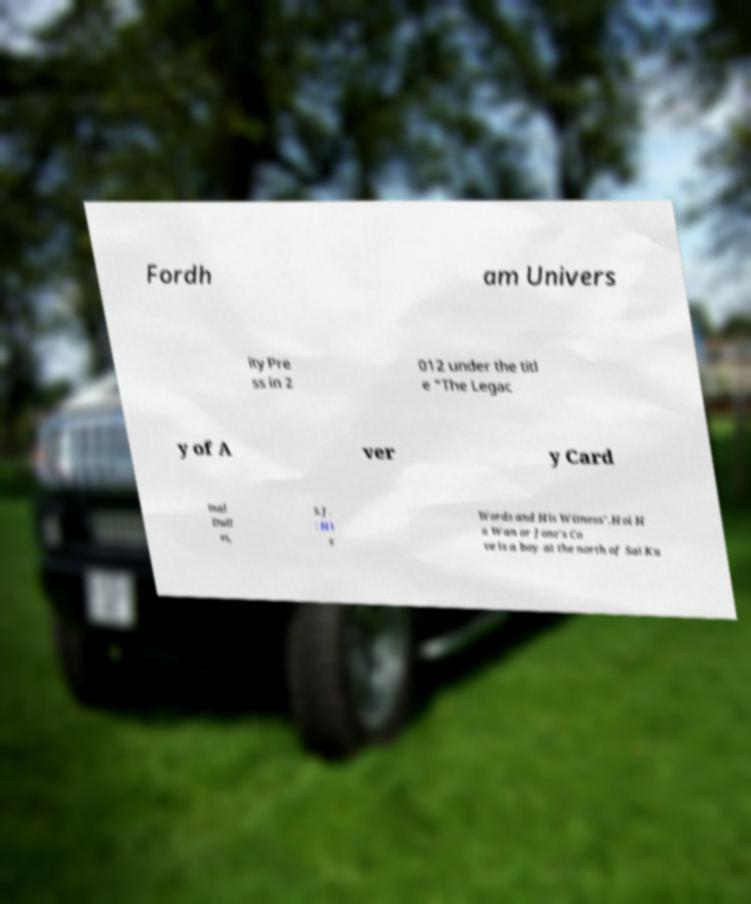For documentation purposes, I need the text within this image transcribed. Could you provide that? Fordh am Univers ity Pre ss in 2 012 under the titl e "The Legac y of A ver y Card inal Dull es, S.J. : Hi s Words and His Witness".Hoi H a Wan or Jone's Co ve is a bay at the north of Sai Ku 